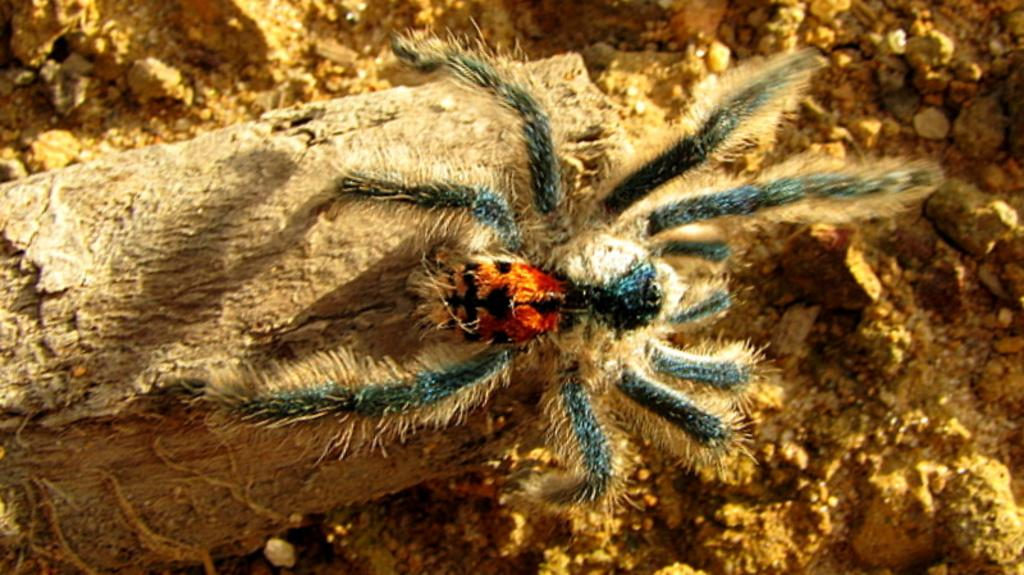What is the main subject of the image? The main subject of the image is a spider. What type of surface is the spider on? The spider is on a wooden surface. How is the spider visually distinct in the image? The spider is in different colors. What type of cart is the spider using to travel in the image? There is no cart present in the image, and the spider is not shown to be traveling. Is the spider holding an umbrella in the image? There is no umbrella present in the image. What religious symbol can be seen in the image? There is no religious symbol present in the image. 